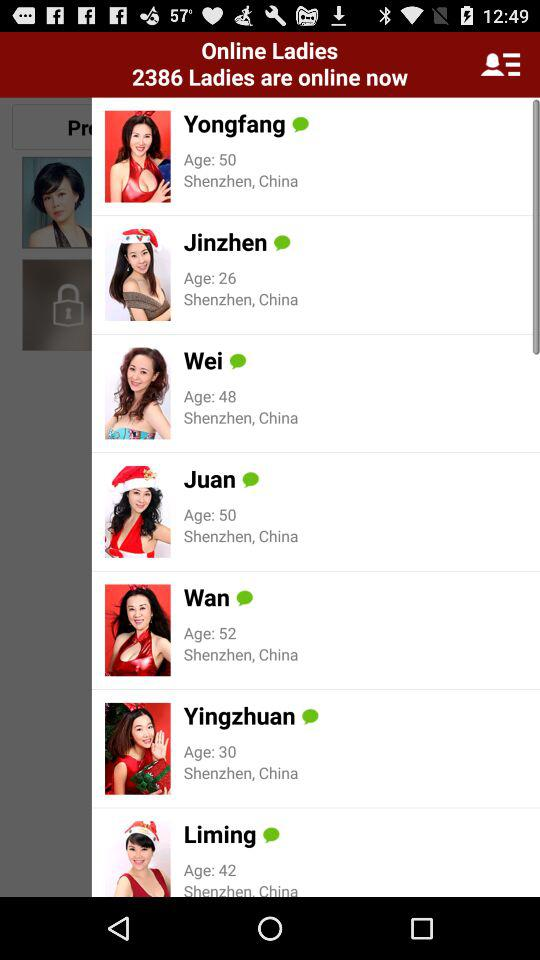What is the age of Wei? The age is 48. 